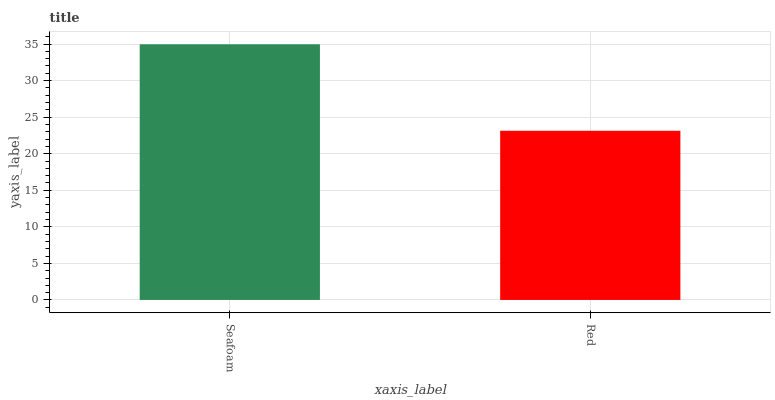Is Red the minimum?
Answer yes or no. Yes. Is Seafoam the maximum?
Answer yes or no. Yes. Is Red the maximum?
Answer yes or no. No. Is Seafoam greater than Red?
Answer yes or no. Yes. Is Red less than Seafoam?
Answer yes or no. Yes. Is Red greater than Seafoam?
Answer yes or no. No. Is Seafoam less than Red?
Answer yes or no. No. Is Seafoam the high median?
Answer yes or no. Yes. Is Red the low median?
Answer yes or no. Yes. Is Red the high median?
Answer yes or no. No. Is Seafoam the low median?
Answer yes or no. No. 